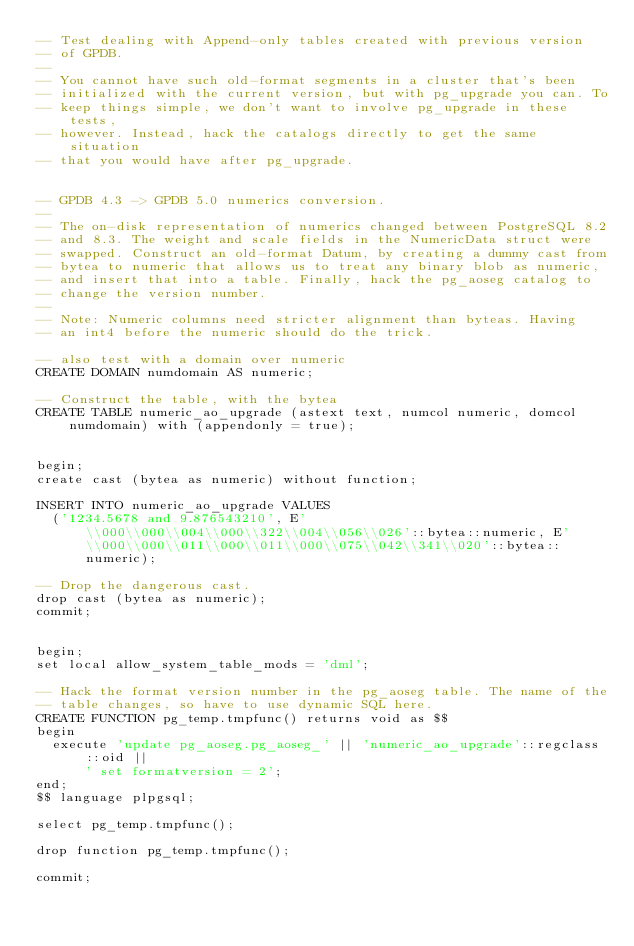<code> <loc_0><loc_0><loc_500><loc_500><_SQL_>-- Test dealing with Append-only tables created with previous version
-- of GPDB.
--
-- You cannot have such old-format segments in a cluster that's been
-- initialized with the current version, but with pg_upgrade you can. To
-- keep things simple, we don't want to involve pg_upgrade in these tests,
-- however. Instead, hack the catalogs directly to get the same situation
-- that you would have after pg_upgrade.


-- GPDB 4.3 -> GPDB 5.0 numerics conversion.
--
-- The on-disk representation of numerics changed between PostgreSQL 8.2
-- and 8.3. The weight and scale fields in the NumericData struct were
-- swapped. Construct an old-format Datum, by creating a dummy cast from
-- bytea to numeric that allows us to treat any binary blob as numeric,
-- and insert that into a table. Finally, hack the pg_aoseg catalog to
-- change the version number.
--
-- Note: Numeric columns need stricter alignment than byteas. Having
-- an int4 before the numeric should do the trick.

-- also test with a domain over numeric
CREATE DOMAIN numdomain AS numeric;

-- Construct the table, with the bytea
CREATE TABLE numeric_ao_upgrade (astext text, numcol numeric, domcol numdomain) with (appendonly = true);


begin;
create cast (bytea as numeric) without function;

INSERT INTO numeric_ao_upgrade VALUES
  ('1234.5678 and 9.876543210', E'\\000\\000\\004\\000\\322\\004\\056\\026'::bytea::numeric, E'\\000\\000\\011\\000\\011\\000\\075\\042\\341\\020'::bytea::numeric);

-- Drop the dangerous cast.
drop cast (bytea as numeric);
commit;


begin;
set local allow_system_table_mods = 'dml';

-- Hack the format version number in the pg_aoseg table. The name of the
-- table changes, so have to use dynamic SQL here.
CREATE FUNCTION pg_temp.tmpfunc() returns void as $$
begin
  execute 'update pg_aoseg.pg_aoseg_' || 'numeric_ao_upgrade'::regclass::oid ||
  	  ' set formatversion = 2';
end;
$$ language plpgsql;

select pg_temp.tmpfunc();

drop function pg_temp.tmpfunc();

commit;
</code> 